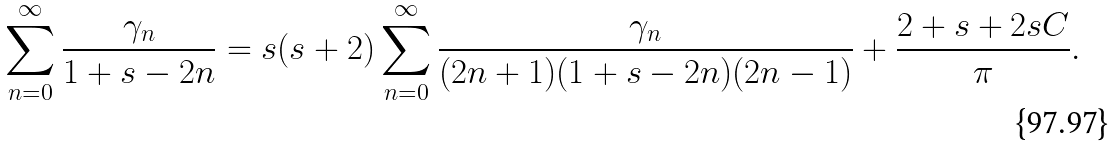Convert formula to latex. <formula><loc_0><loc_0><loc_500><loc_500>\sum _ { n = 0 } ^ { \infty } { \frac { \gamma _ { n } } { 1 + s - 2 n } } & = s ( s + 2 ) \sum _ { n = 0 } ^ { \infty } { \frac { \gamma _ { n } } { ( 2 n + 1 ) ( 1 + s - 2 n ) ( 2 n - 1 ) } } + \frac { 2 + s + 2 s C } { \pi } .</formula> 